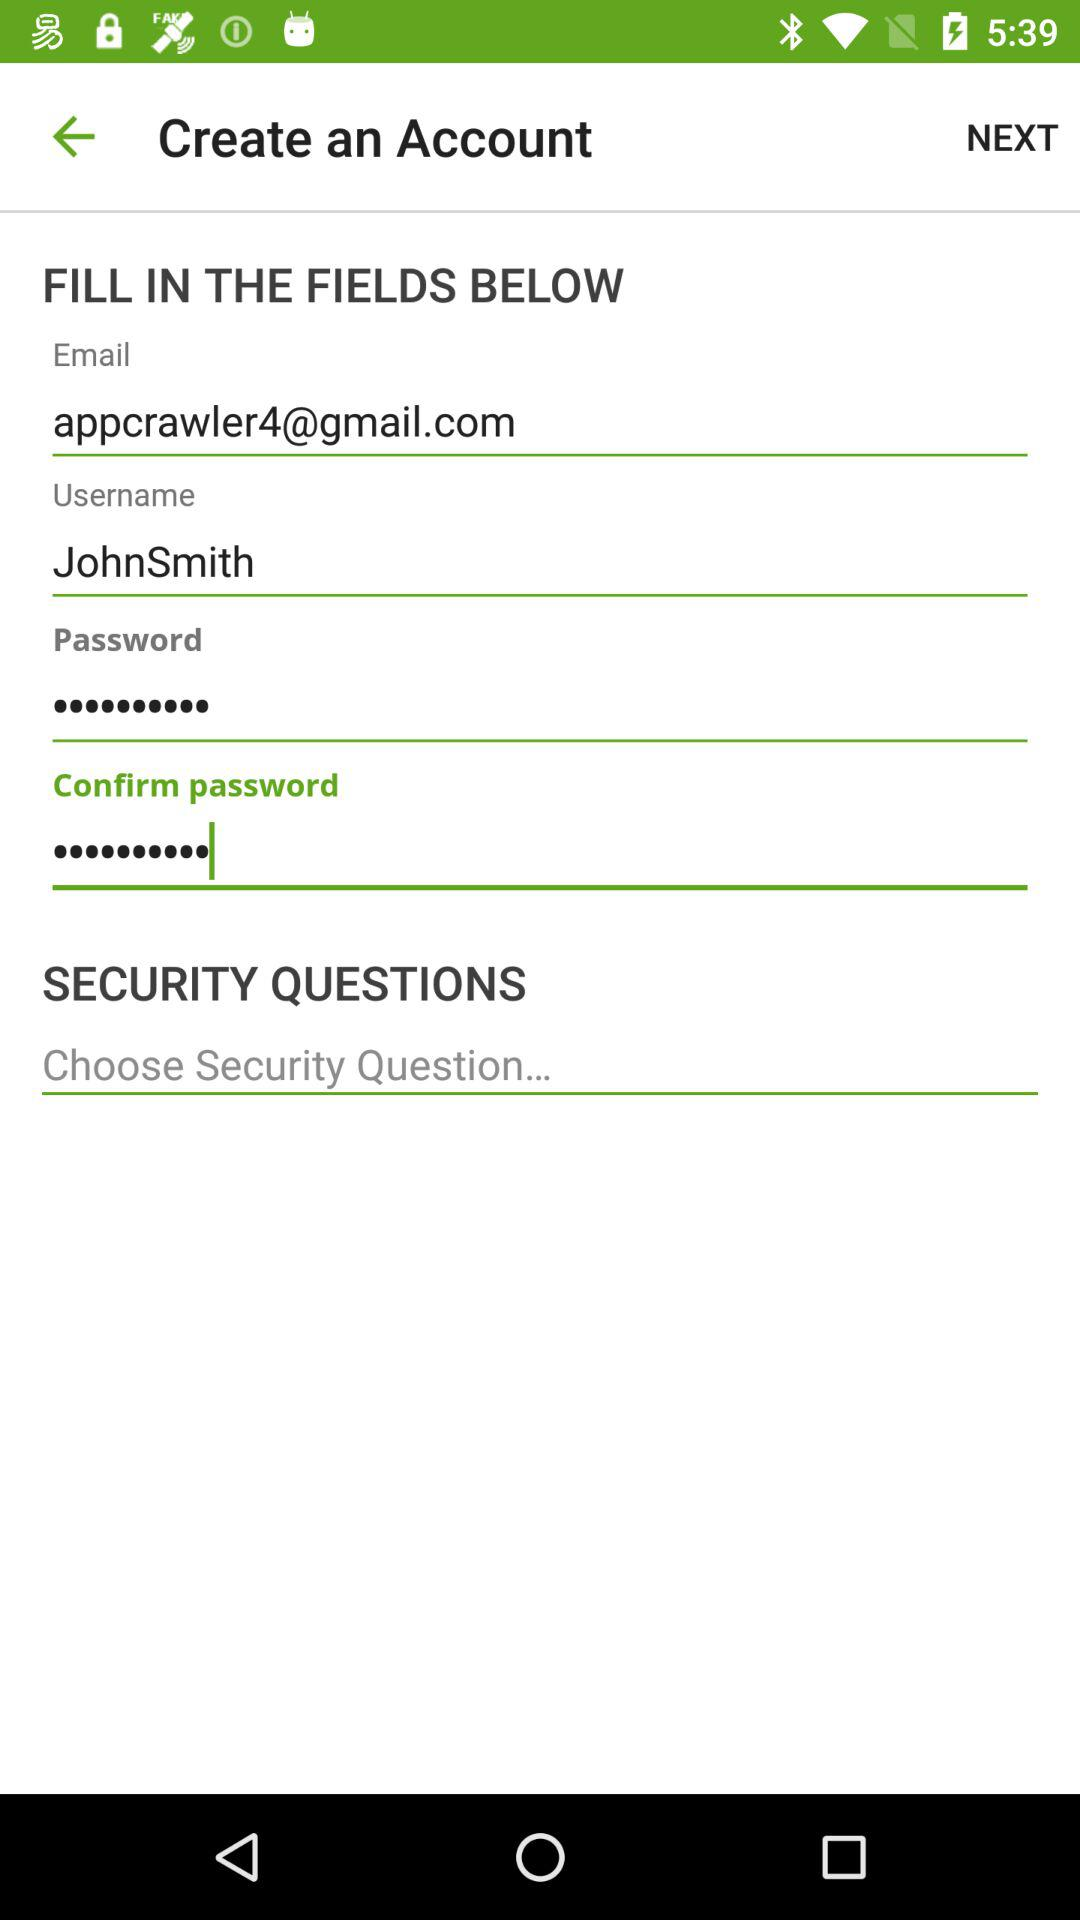What is the username? The username is "JohnSmith". 